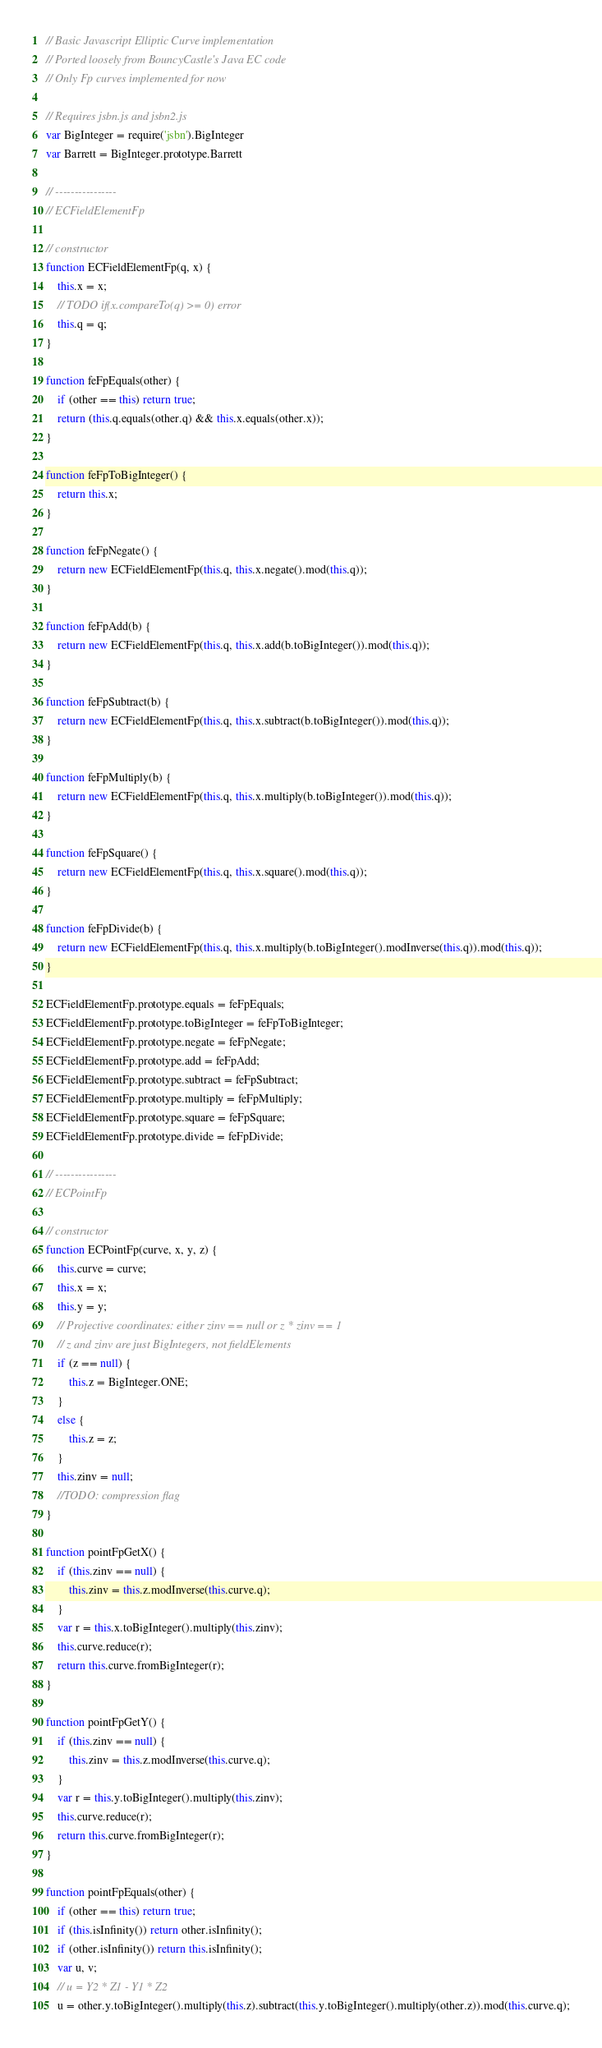<code> <loc_0><loc_0><loc_500><loc_500><_JavaScript_>// Basic Javascript Elliptic Curve implementation
// Ported loosely from BouncyCastle's Java EC code
// Only Fp curves implemented for now

// Requires jsbn.js and jsbn2.js
var BigInteger = require('jsbn').BigInteger
var Barrett = BigInteger.prototype.Barrett

// ----------------
// ECFieldElementFp

// constructor
function ECFieldElementFp(q, x) {
    this.x = x;
    // TODO if(x.compareTo(q) >= 0) error
    this.q = q;
}

function feFpEquals(other) {
    if (other == this) return true;
    return (this.q.equals(other.q) && this.x.equals(other.x));
}

function feFpToBigInteger() {
    return this.x;
}

function feFpNegate() {
    return new ECFieldElementFp(this.q, this.x.negate().mod(this.q));
}

function feFpAdd(b) {
    return new ECFieldElementFp(this.q, this.x.add(b.toBigInteger()).mod(this.q));
}

function feFpSubtract(b) {
    return new ECFieldElementFp(this.q, this.x.subtract(b.toBigInteger()).mod(this.q));
}

function feFpMultiply(b) {
    return new ECFieldElementFp(this.q, this.x.multiply(b.toBigInteger()).mod(this.q));
}

function feFpSquare() {
    return new ECFieldElementFp(this.q, this.x.square().mod(this.q));
}

function feFpDivide(b) {
    return new ECFieldElementFp(this.q, this.x.multiply(b.toBigInteger().modInverse(this.q)).mod(this.q));
}

ECFieldElementFp.prototype.equals = feFpEquals;
ECFieldElementFp.prototype.toBigInteger = feFpToBigInteger;
ECFieldElementFp.prototype.negate = feFpNegate;
ECFieldElementFp.prototype.add = feFpAdd;
ECFieldElementFp.prototype.subtract = feFpSubtract;
ECFieldElementFp.prototype.multiply = feFpMultiply;
ECFieldElementFp.prototype.square = feFpSquare;
ECFieldElementFp.prototype.divide = feFpDivide;

// ----------------
// ECPointFp

// constructor
function ECPointFp(curve, x, y, z) {
    this.curve = curve;
    this.x = x;
    this.y = y;
    // Projective coordinates: either zinv == null or z * zinv == 1
    // z and zinv are just BigIntegers, not fieldElements
    if (z == null) {
        this.z = BigInteger.ONE;
    }
    else {
        this.z = z;
    }
    this.zinv = null;
    //TODO: compression flag
}

function pointFpGetX() {
    if (this.zinv == null) {
        this.zinv = this.z.modInverse(this.curve.q);
    }
    var r = this.x.toBigInteger().multiply(this.zinv);
    this.curve.reduce(r);
    return this.curve.fromBigInteger(r);
}

function pointFpGetY() {
    if (this.zinv == null) {
        this.zinv = this.z.modInverse(this.curve.q);
    }
    var r = this.y.toBigInteger().multiply(this.zinv);
    this.curve.reduce(r);
    return this.curve.fromBigInteger(r);
}

function pointFpEquals(other) {
    if (other == this) return true;
    if (this.isInfinity()) return other.isInfinity();
    if (other.isInfinity()) return this.isInfinity();
    var u, v;
    // u = Y2 * Z1 - Y1 * Z2
    u = other.y.toBigInteger().multiply(this.z).subtract(this.y.toBigInteger().multiply(other.z)).mod(this.curve.q);</code> 